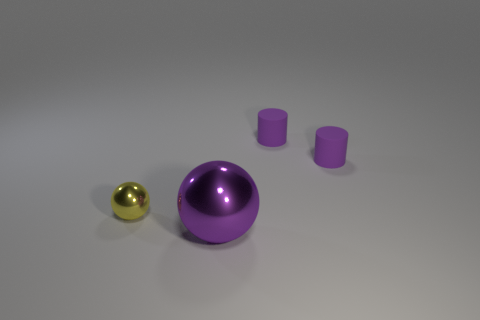Subtract all cyan spheres. Subtract all cyan cubes. How many spheres are left? 2 Add 4 tiny rubber objects. How many objects exist? 8 Add 4 purple objects. How many purple objects exist? 7 Subtract 0 gray cylinders. How many objects are left? 4 Subtract all purple metallic balls. Subtract all large purple metallic objects. How many objects are left? 2 Add 2 big purple things. How many big purple things are left? 3 